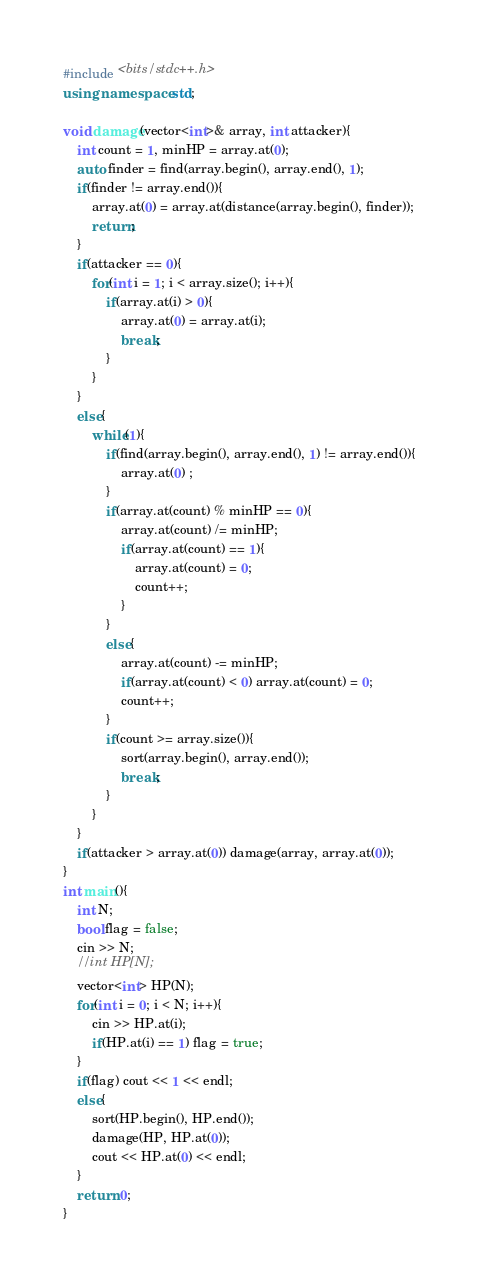Convert code to text. <code><loc_0><loc_0><loc_500><loc_500><_C++_>#include <bits/stdc++.h>
using namespace std;

void damage(vector<int>& array, int attacker){
    int count = 1, minHP = array.at(0);
    auto finder = find(array.begin(), array.end(), 1);
    if(finder != array.end()){
        array.at(0) = array.at(distance(array.begin(), finder));
        return;
    }
    if(attacker == 0){
        for(int i = 1; i < array.size(); i++){
            if(array.at(i) > 0){
                array.at(0) = array.at(i);
                break;
            }
        }
    }
    else{
        while(1){
            if(find(array.begin(), array.end(), 1) != array.end()){
                array.at(0) ;
            }
            if(array.at(count) % minHP == 0){
                array.at(count) /= minHP;
                if(array.at(count) == 1){
                    array.at(count) = 0;
                    count++;
                }
            }
            else{
                array.at(count) -= minHP;
                if(array.at(count) < 0) array.at(count) = 0;
                count++;
            }
            if(count >= array.size()){
                sort(array.begin(), array.end());
                break;
            }
        }
    }
    if(attacker > array.at(0)) damage(array, array.at(0));
}
int main(){
    int N;
    bool flag = false;
    cin >> N;
    //int HP[N];
    vector<int> HP(N);
    for(int i = 0; i < N; i++){
        cin >> HP.at(i);
        if(HP.at(i) == 1) flag = true;
    }
    if(flag) cout << 1 << endl;
    else{
        sort(HP.begin(), HP.end());
        damage(HP, HP.at(0));
        cout << HP.at(0) << endl;
    }
    return 0;
}</code> 